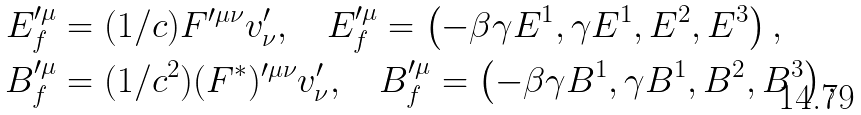Convert formula to latex. <formula><loc_0><loc_0><loc_500><loc_500>E _ { f } ^ { \prime \mu } & = ( 1 / c ) F ^ { \prime \mu \nu } v _ { \nu } ^ { \prime } , \quad E _ { f } ^ { \prime \mu } = \left ( - \beta \gamma E ^ { 1 } , \gamma E ^ { 1 } , E ^ { 2 } , E ^ { 3 } \right ) , \\ B _ { f } ^ { \prime \mu } & = ( 1 / c ^ { 2 } ) ( F ^ { \ast } ) ^ { \prime \mu \nu } v _ { \nu } ^ { \prime } , \quad B _ { f } ^ { \prime \mu } = \left ( - \beta \gamma B ^ { 1 } , \gamma B ^ { 1 } , B ^ { 2 } , B ^ { 3 } \right ) ,</formula> 